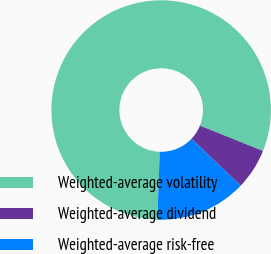Convert chart to OTSL. <chart><loc_0><loc_0><loc_500><loc_500><pie_chart><fcel>Weighted-average volatility<fcel>Weighted-average dividend<fcel>Weighted-average risk-free<nl><fcel>80.54%<fcel>6.01%<fcel>13.45%<nl></chart> 